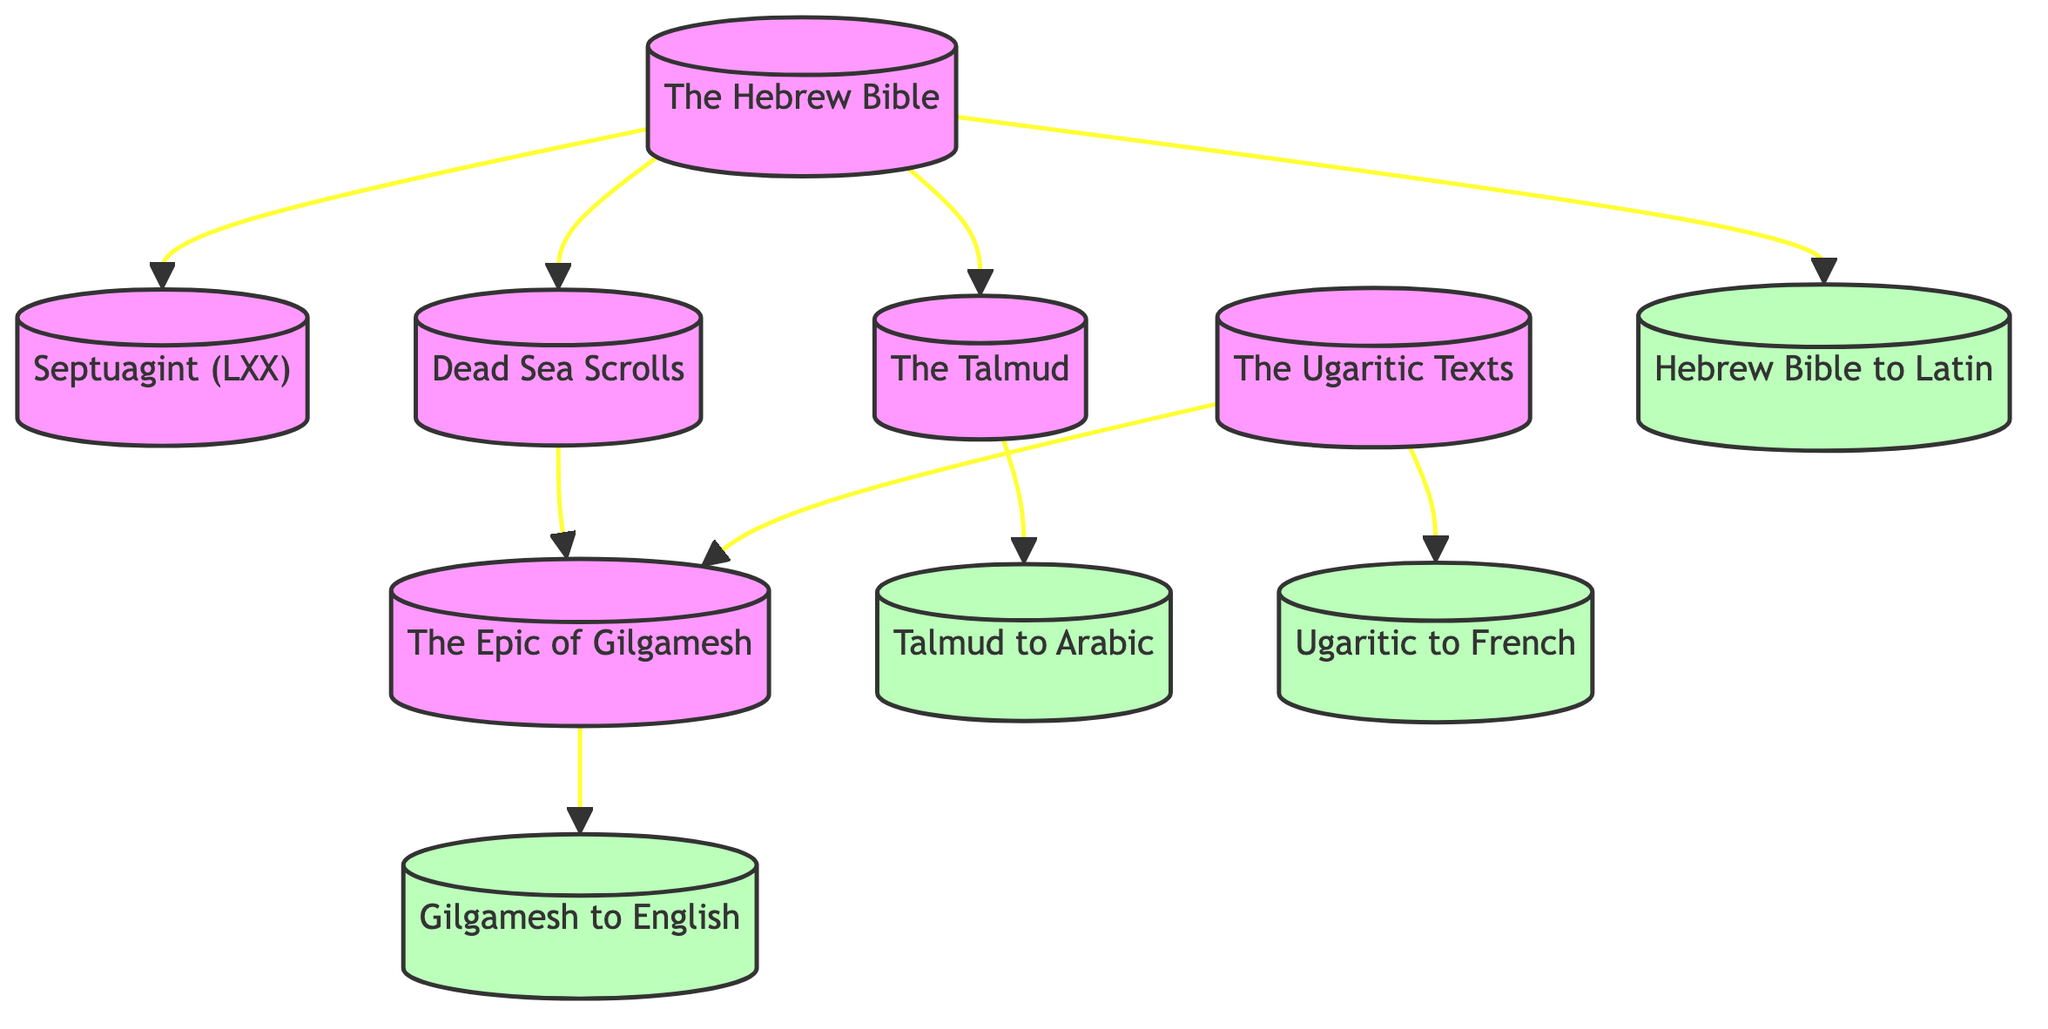What is the total number of nodes in the diagram? The diagram lists 10 unique texts or translations, which can be counted from the nodes section of the data.
Answer: 10 Which text is directly translated into Arabic? The edge from "The Talmud" to "Translation of the Talmud into Arabic" indicates that this translation is a direct relationship.
Answer: Translation of the Talmud into Arabic How many translations are derived from the Hebrew Bible? Analyzing the edges, the Hebrew Bible is connected to three translations: the Septuagint (LXX), Translation of the Hebrew Bible into Latin, and Dead Sea Scrolls.
Answer: 3 Which two texts share a direct connection through the Dead Sea Scrolls? The diagram shows edges from the Dead Sea Scrolls to both "The Epic of Gilgamesh" and "The Hebrew Bible", indicating a connection between them via the Dead Sea Scrolls.
Answer: The Epic of Gilgamesh From which ancient text does the English translation of the Epic of Gilgamesh originate? Observing the edge from "The Epic of Gilgamesh" to "Translation of the Epic of Gilgamesh into English", it is clear that this translation stems directly from the Epic of Gilgamesh.
Answer: The Epic of Gilgamesh What type of relationship is present between the Ugaritic texts and their French translation? The connection from "The Ugaritic Texts" to "Translation of Ugaritic Texts into French" demonstrates a direct translation relationship.
Answer: Direct translation How many edges are connected to the Hebrew Bible? Counting the edges that originate from the Hebrew Bible, which are three (to the Septuagint, Dead Sea Scrolls, and the Latin translation), this indicates multiple relationships stemming from this text.
Answer: 3 Which translation specifically links Sumerian literature to an English audience? The edge from "The Epic of Gilgamesh" to "Translation of the Epic of Gilgamesh into English" explicitly illustrates this connection, highlighting the Sumerian literary work's pathway to English.
Answer: Translation of the Epic of Gilgamesh into English What does the direct edge from the Dead Sea Scrolls to the Epic of Gilgamesh suggest? The direct edge indicates that there is a historical or textual relationship connecting the Dead Sea Scrolls to the Epic of Gilgamesh, possibly highlighting their respective cultural contexts.
Answer: Historical/textual relationship 